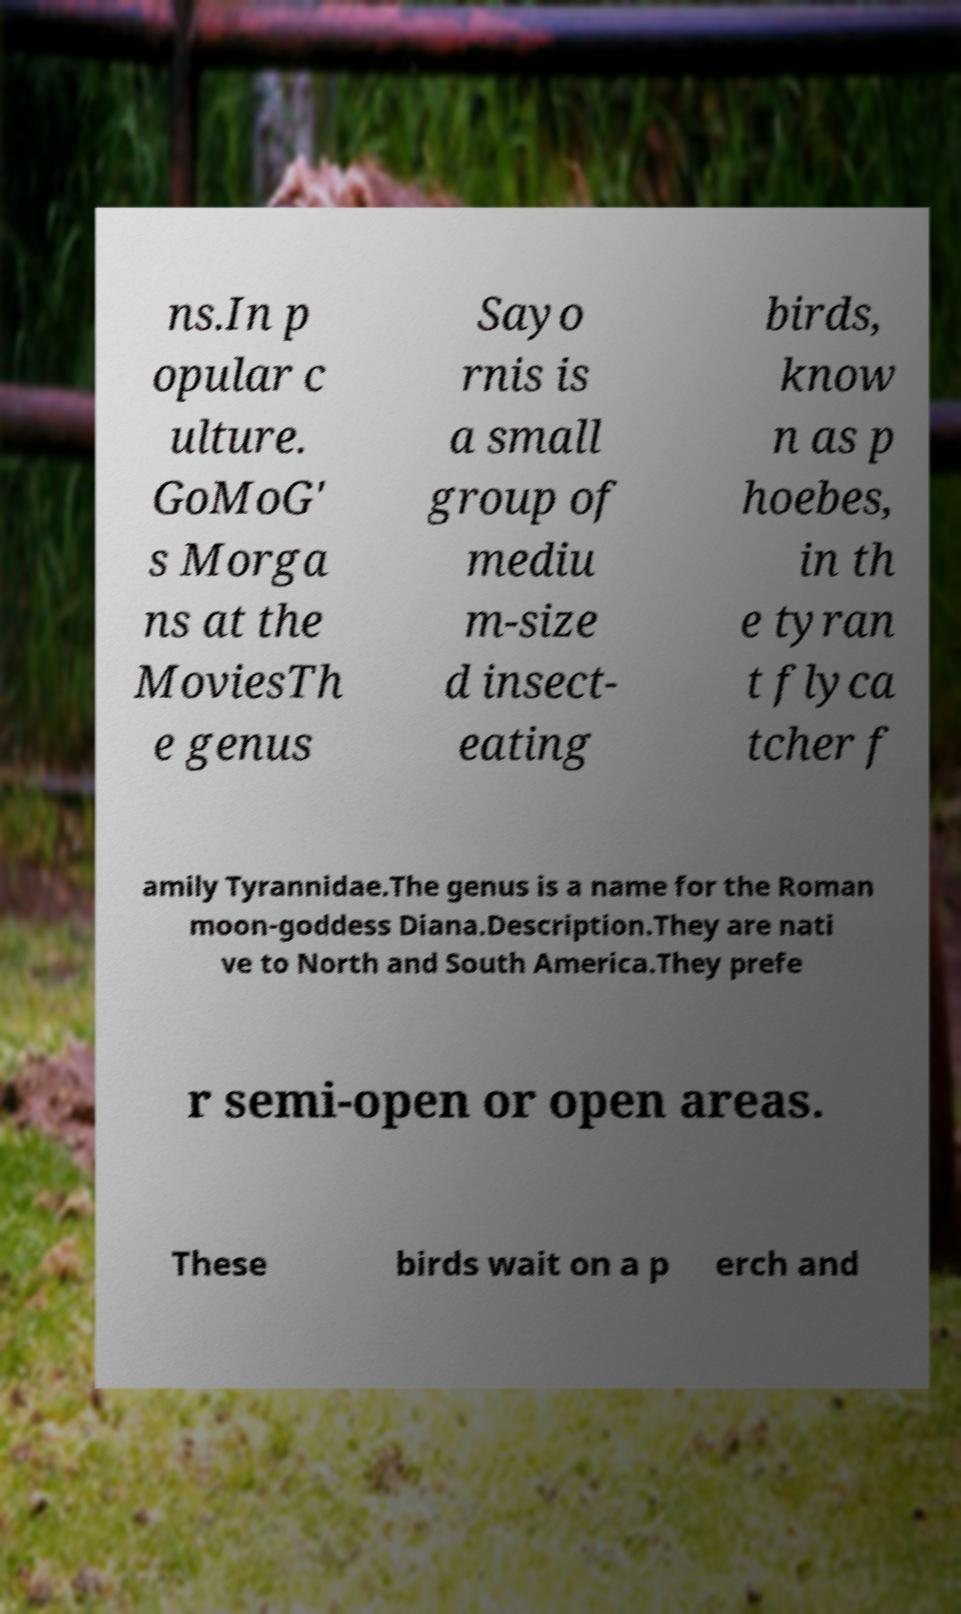Could you extract and type out the text from this image? ns.In p opular c ulture. GoMoG' s Morga ns at the MoviesTh e genus Sayo rnis is a small group of mediu m-size d insect- eating birds, know n as p hoebes, in th e tyran t flyca tcher f amily Tyrannidae.The genus is a name for the Roman moon-goddess Diana.Description.They are nati ve to North and South America.They prefe r semi-open or open areas. These birds wait on a p erch and 